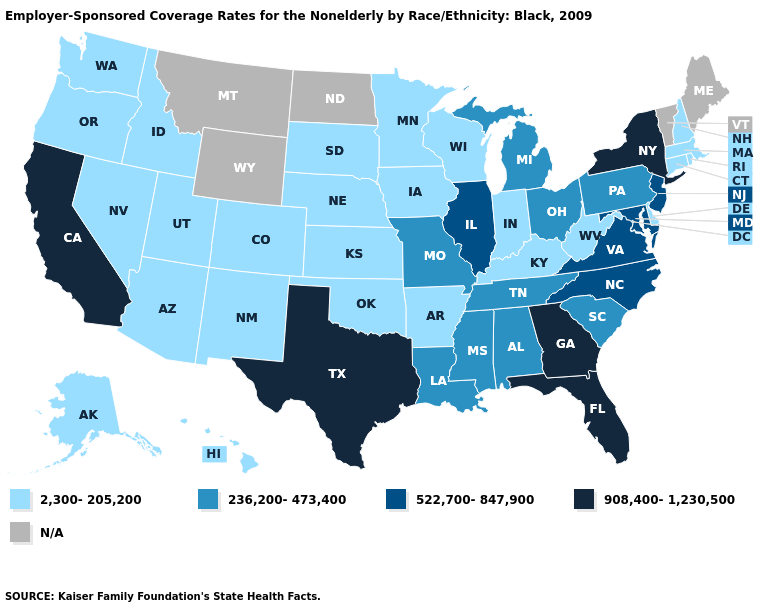Does Idaho have the lowest value in the USA?
Concise answer only. Yes. Name the states that have a value in the range N/A?
Give a very brief answer. Maine, Montana, North Dakota, Vermont, Wyoming. Name the states that have a value in the range 522,700-847,900?
Be succinct. Illinois, Maryland, New Jersey, North Carolina, Virginia. Name the states that have a value in the range 236,200-473,400?
Give a very brief answer. Alabama, Louisiana, Michigan, Mississippi, Missouri, Ohio, Pennsylvania, South Carolina, Tennessee. What is the value of Missouri?
Answer briefly. 236,200-473,400. What is the value of Alabama?
Write a very short answer. 236,200-473,400. Name the states that have a value in the range 908,400-1,230,500?
Answer briefly. California, Florida, Georgia, New York, Texas. What is the value of Arizona?
Short answer required. 2,300-205,200. Name the states that have a value in the range N/A?
Short answer required. Maine, Montana, North Dakota, Vermont, Wyoming. Name the states that have a value in the range 908,400-1,230,500?
Write a very short answer. California, Florida, Georgia, New York, Texas. Name the states that have a value in the range 236,200-473,400?
Write a very short answer. Alabama, Louisiana, Michigan, Mississippi, Missouri, Ohio, Pennsylvania, South Carolina, Tennessee. Among the states that border Delaware , which have the lowest value?
Quick response, please. Pennsylvania. Does New Hampshire have the highest value in the Northeast?
Give a very brief answer. No. Which states have the lowest value in the Northeast?
Quick response, please. Connecticut, Massachusetts, New Hampshire, Rhode Island. What is the value of West Virginia?
Answer briefly. 2,300-205,200. 